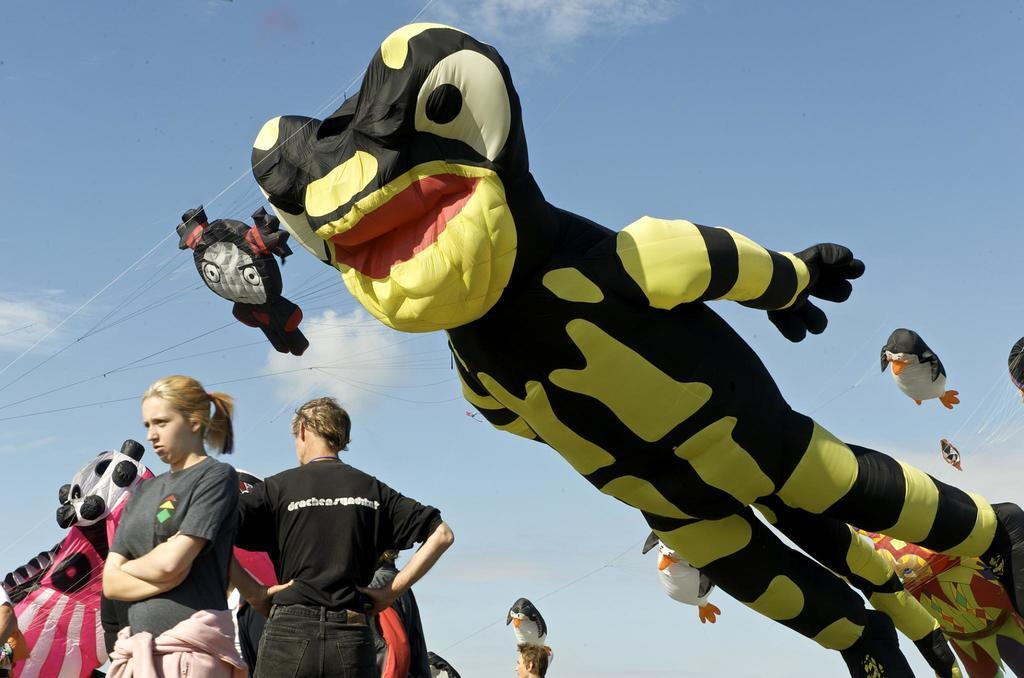What is the main subject in the center of the image? There are air balloons in the center of the image. What can be seen at the bottom of the image? There are persons at the bottom of the image. Are there any other air balloons visible in the image? Yes, there are air balloons in the background of the image. What is visible in the background of the image? The sky and clouds are visible in the background of the image. What type of crime is being committed in the image? There is no indication of any crime being committed in the image; it features air balloons and persons. What operation is being performed on the beds in the image? There are no beds present in the image, so no operation can be performed on them. 